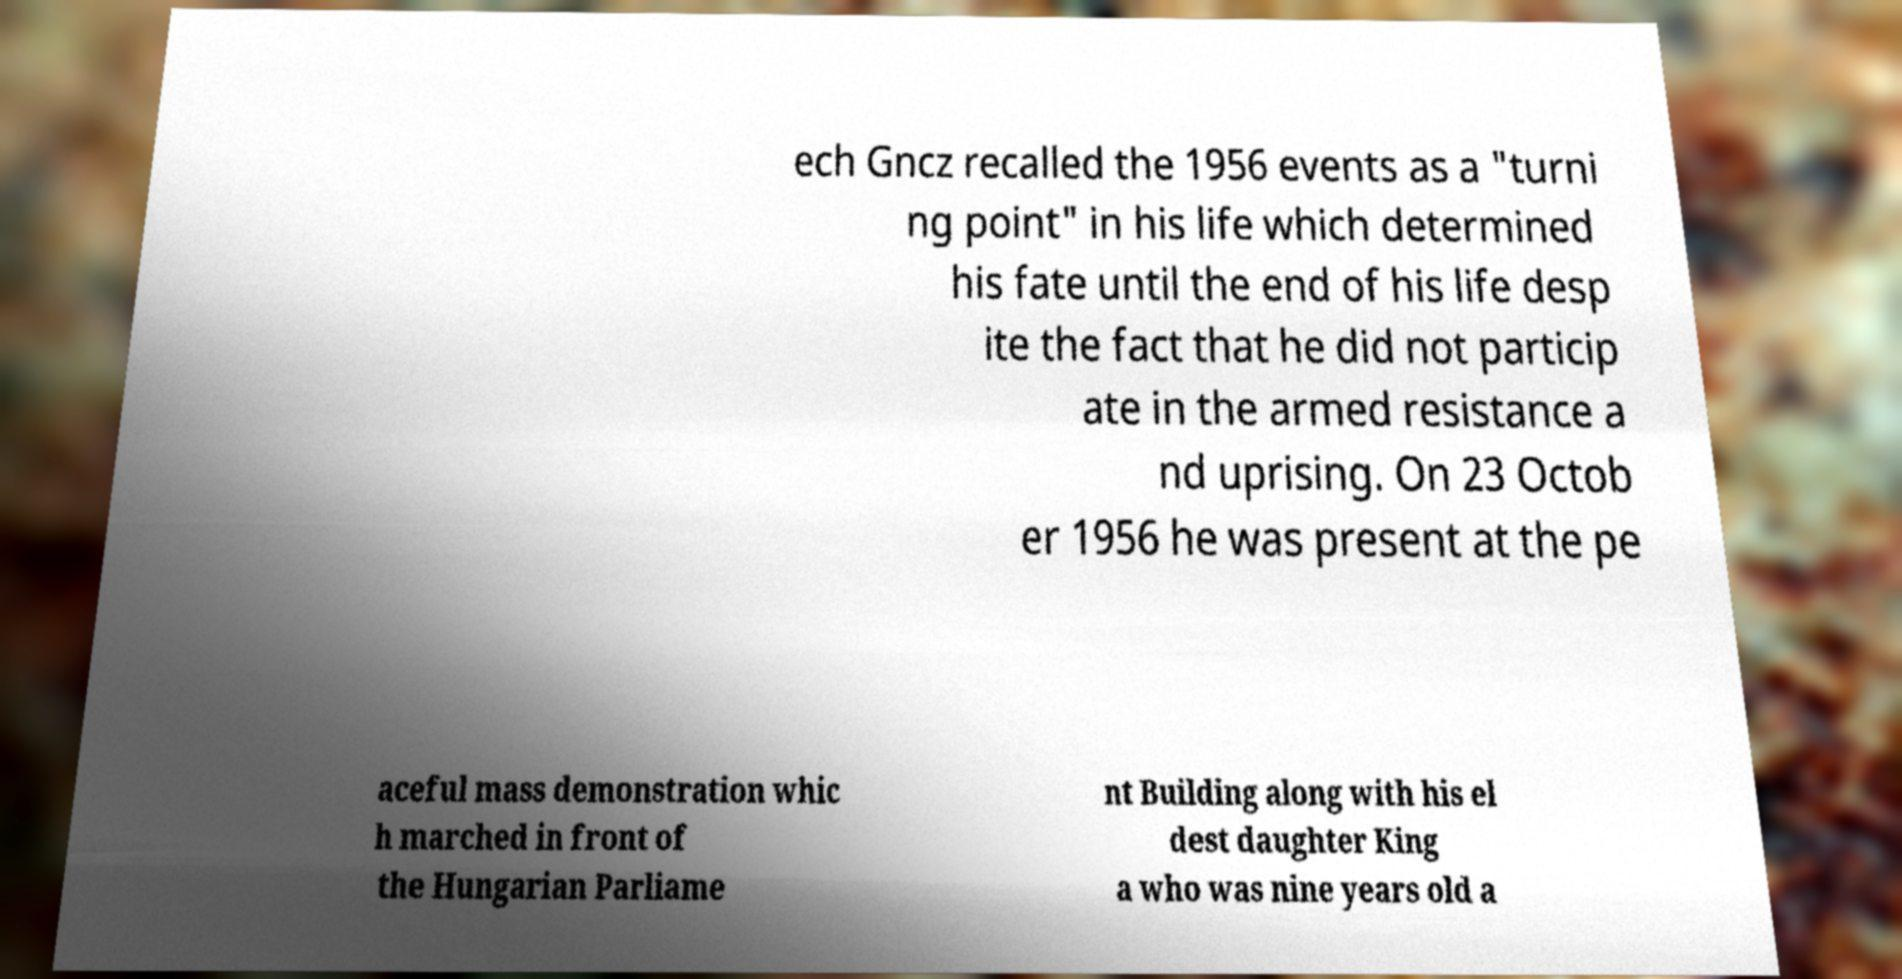Please read and relay the text visible in this image. What does it say? ech Gncz recalled the 1956 events as a "turni ng point" in his life which determined his fate until the end of his life desp ite the fact that he did not particip ate in the armed resistance a nd uprising. On 23 Octob er 1956 he was present at the pe aceful mass demonstration whic h marched in front of the Hungarian Parliame nt Building along with his el dest daughter King a who was nine years old a 